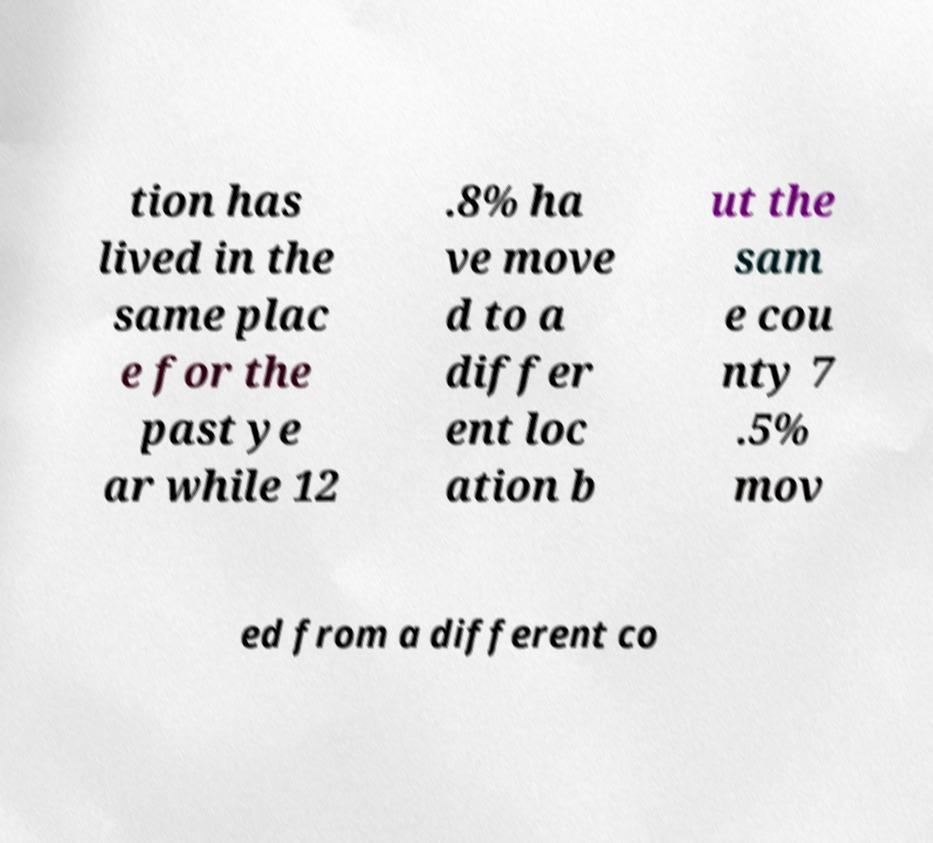Please identify and transcribe the text found in this image. tion has lived in the same plac e for the past ye ar while 12 .8% ha ve move d to a differ ent loc ation b ut the sam e cou nty 7 .5% mov ed from a different co 